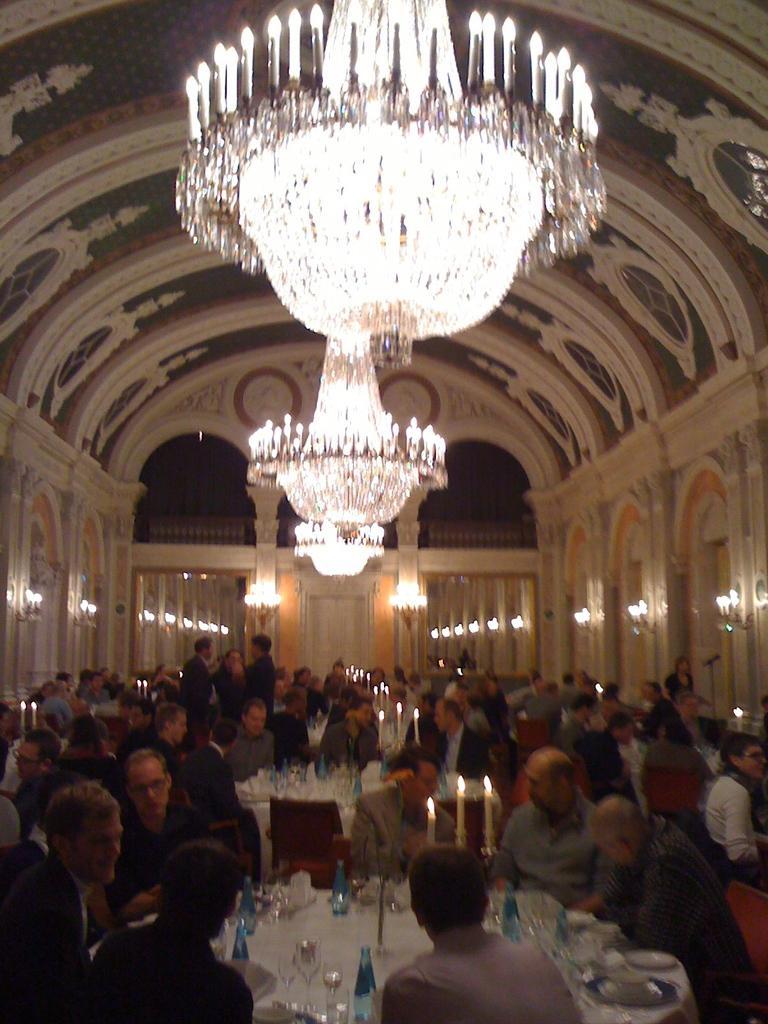Could you give a brief overview of what you see in this image? At the top we can see a well designed ceiling and a ceiling lights. Here we can see persons standing and sitting on chairs in front of a table and on the table we can see glasses, bottles, candles on a stand. Here we can see a mike. 